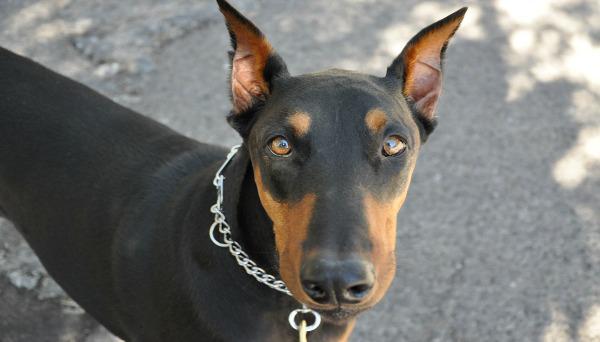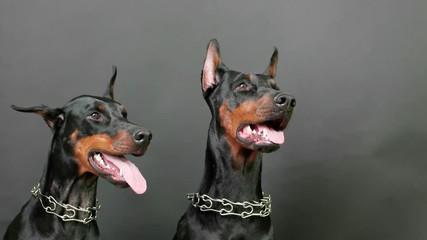The first image is the image on the left, the second image is the image on the right. For the images shown, is this caption "At least one doberman has its tongue out." true? Answer yes or no. Yes. The first image is the image on the left, the second image is the image on the right. Given the left and right images, does the statement "Each image shows at least one doberman wearing a collar, and one image shows a camera-gazing close-mouthed dog in a chain collar, while the other image includes a rightward-gazing dog with its pink tongue hanging out." hold true? Answer yes or no. Yes. 